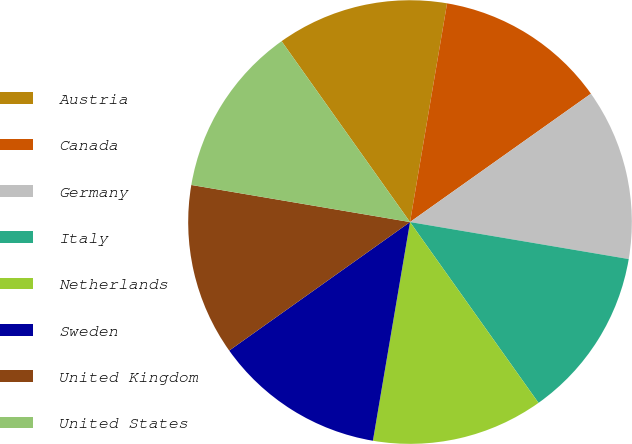Convert chart to OTSL. <chart><loc_0><loc_0><loc_500><loc_500><pie_chart><fcel>Austria<fcel>Canada<fcel>Germany<fcel>Italy<fcel>Netherlands<fcel>Sweden<fcel>United Kingdom<fcel>United States<nl><fcel>12.5%<fcel>12.51%<fcel>12.49%<fcel>12.5%<fcel>12.51%<fcel>12.49%<fcel>12.51%<fcel>12.5%<nl></chart> 